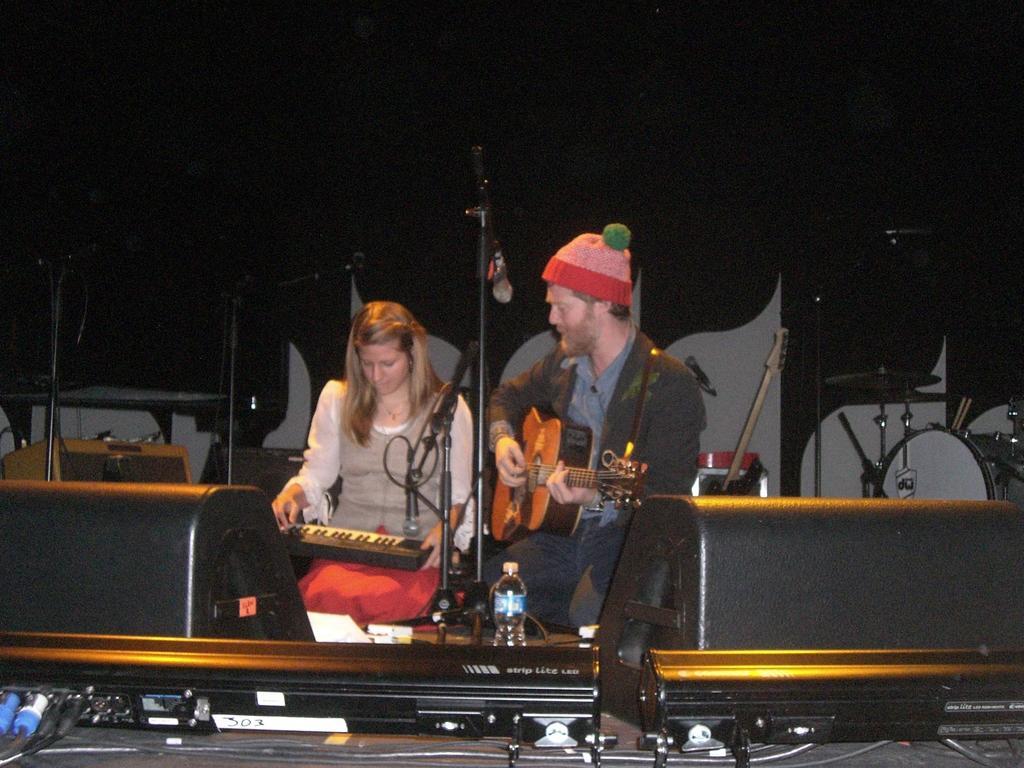Can you describe this image briefly? Background portion of the picture is completely dark. We can see a man and a woman playing musical instruments. We can see musical instruments and few other electronic devices, water bottle and mics with stands. 